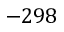Convert formula to latex. <formula><loc_0><loc_0><loc_500><loc_500>- 2 9 8</formula> 